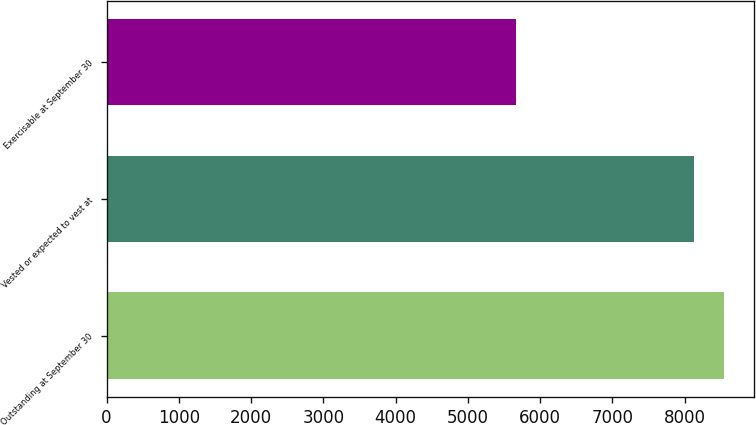<chart> <loc_0><loc_0><loc_500><loc_500><bar_chart><fcel>Outstanding at September 30<fcel>Vested or expected to vest at<fcel>Exercisable at September 30<nl><fcel>8539.5<fcel>8125<fcel>5665<nl></chart> 